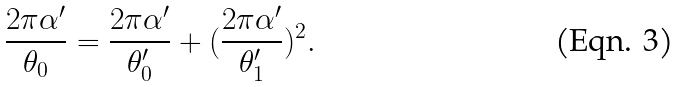<formula> <loc_0><loc_0><loc_500><loc_500>\frac { 2 \pi \alpha ^ { \prime } } { \theta _ { 0 } } = \frac { 2 \pi \alpha ^ { \prime } } { \theta _ { 0 } ^ { \prime } } + ( \frac { 2 \pi \alpha ^ { \prime } } { \theta _ { 1 } ^ { \prime } } ) ^ { 2 } .</formula> 